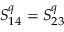Convert formula to latex. <formula><loc_0><loc_0><loc_500><loc_500>S _ { 1 4 } ^ { q } = S _ { 2 3 } ^ { q }</formula> 